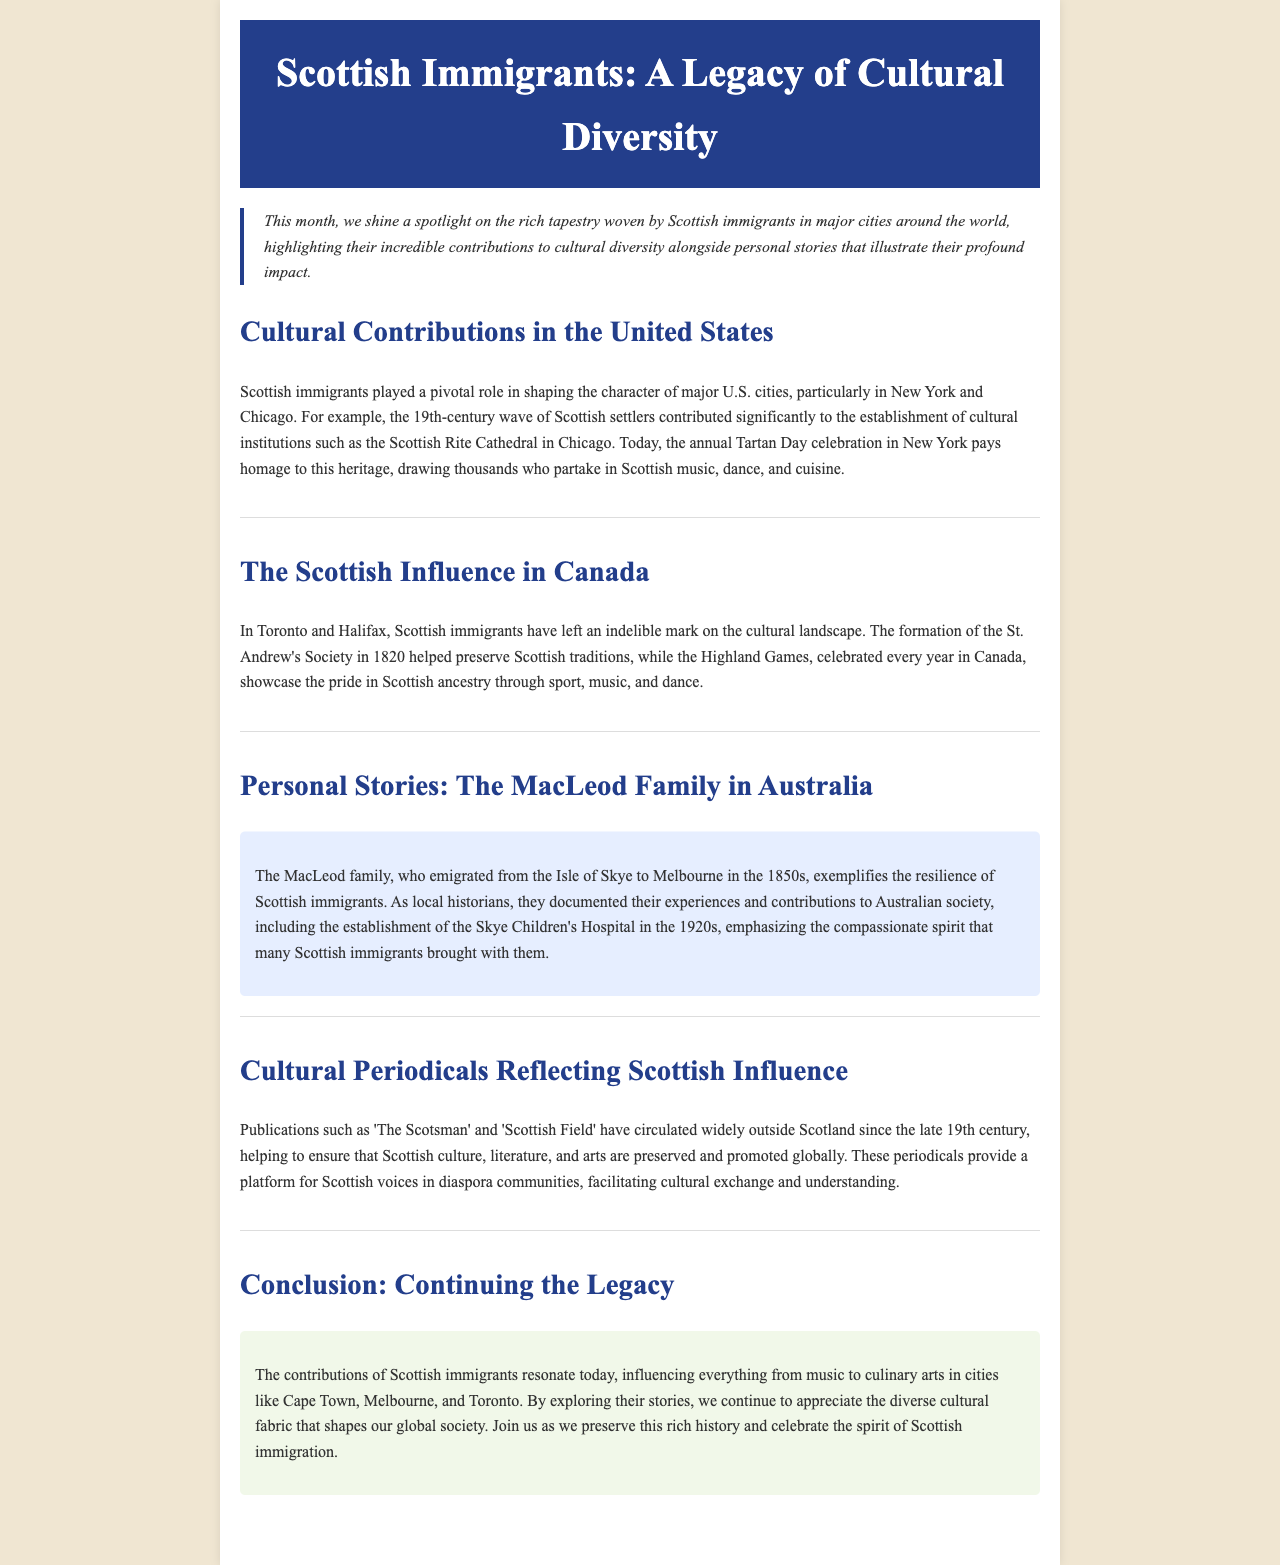what cultural institution was established by Scottish settlers in Chicago? The document mentions the Scottish Rite Cathedral as a significant cultural institution established by Scottish settlers in Chicago.
Answer: Scottish Rite Cathedral when was the St. Andrew's Society formed in Canada? The document states that the St. Andrew's Society was formed in 1820, which helped preserve Scottish traditions in Canada.
Answer: 1820 what family is mentioned as an example of Scottish immigrants in Australia? The MacLeod family is highlighted in the document as an exemplary Scottish immigrant family in Australia.
Answer: MacLeod family what event is celebrated annually in New York to honor Scottish heritage? The document refers to the Tartan Day celebration as the annual event in New York that honors Scottish heritage.
Answer: Tartan Day what types of contributions did Scottish immigrants influence according to the conclusion? The conclusion states that Scottish immigrants influenced everything from music to culinary arts in various cities.
Answer: music and culinary arts why is the publication 'The Scotsman' significant outside Scotland? The document explains that 'The Scotsman' and similar publications have circulated widely to help preserve and promote Scottish culture, literature, and arts globally.
Answer: preserve and promote culture what year did the MacLeod family establish a hospital in Australia? The document states that the MacLeod family established the Skye Children's Hospital in the 1920s.
Answer: 1920s which city hosts Highland Games to showcase Scottish ancestry? The document mentions that the Highland Games are celebrated in Canada to showcase pride in Scottish ancestry.
Answer: Canada 